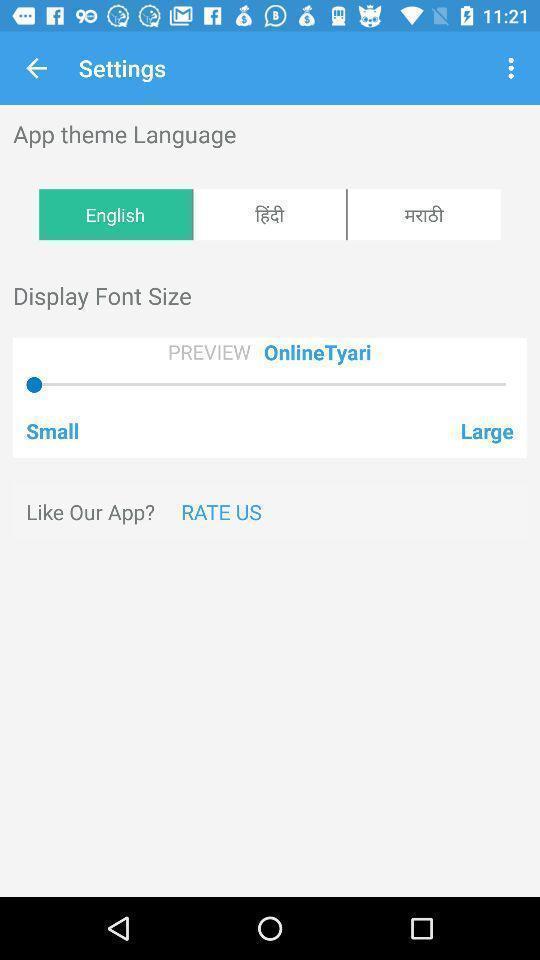Tell me about the visual elements in this screen capture. Settings page with language and font size options. 